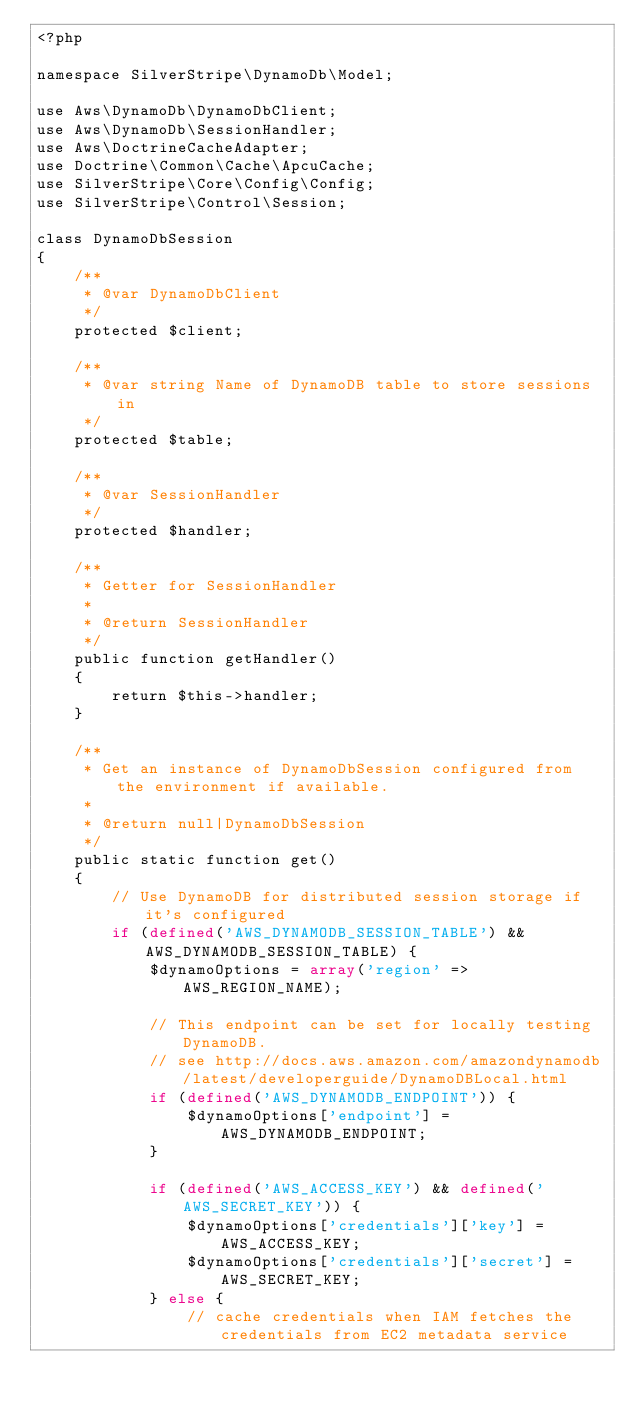Convert code to text. <code><loc_0><loc_0><loc_500><loc_500><_PHP_><?php

namespace SilverStripe\DynamoDb\Model;

use Aws\DynamoDb\DynamoDbClient;
use Aws\DynamoDb\SessionHandler;
use Aws\DoctrineCacheAdapter;
use Doctrine\Common\Cache\ApcuCache;
use SilverStripe\Core\Config\Config;
use SilverStripe\Control\Session;

class DynamoDbSession
{
    /**
     * @var DynamoDbClient
     */
    protected $client;

    /**
     * @var string Name of DynamoDB table to store sessions in
     */
    protected $table;

    /**
     * @var SessionHandler
     */
    protected $handler;

    /**
     * Getter for SessionHandler
     *
     * @return SessionHandler
     */
    public function getHandler()
    {
        return $this->handler;
    }

    /**
     * Get an instance of DynamoDbSession configured from the environment if available.
     *
     * @return null|DynamoDbSession
     */
    public static function get()
    {
        // Use DynamoDB for distributed session storage if it's configured
        if (defined('AWS_DYNAMODB_SESSION_TABLE') && AWS_DYNAMODB_SESSION_TABLE) {
            $dynamoOptions = array('region' => AWS_REGION_NAME);

            // This endpoint can be set for locally testing DynamoDB.
            // see http://docs.aws.amazon.com/amazondynamodb/latest/developerguide/DynamoDBLocal.html
            if (defined('AWS_DYNAMODB_ENDPOINT')) {
                $dynamoOptions['endpoint'] = AWS_DYNAMODB_ENDPOINT;
            }

            if (defined('AWS_ACCESS_KEY') && defined('AWS_SECRET_KEY')) {
                $dynamoOptions['credentials']['key'] = AWS_ACCESS_KEY;
                $dynamoOptions['credentials']['secret'] = AWS_SECRET_KEY;
            } else {
                // cache credentials when IAM fetches the credentials from EC2 metadata service</code> 